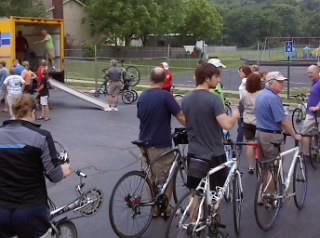Why might these people be lined up?

Choices:
A) repairs
B) race
C) lessons
D) donation donation 